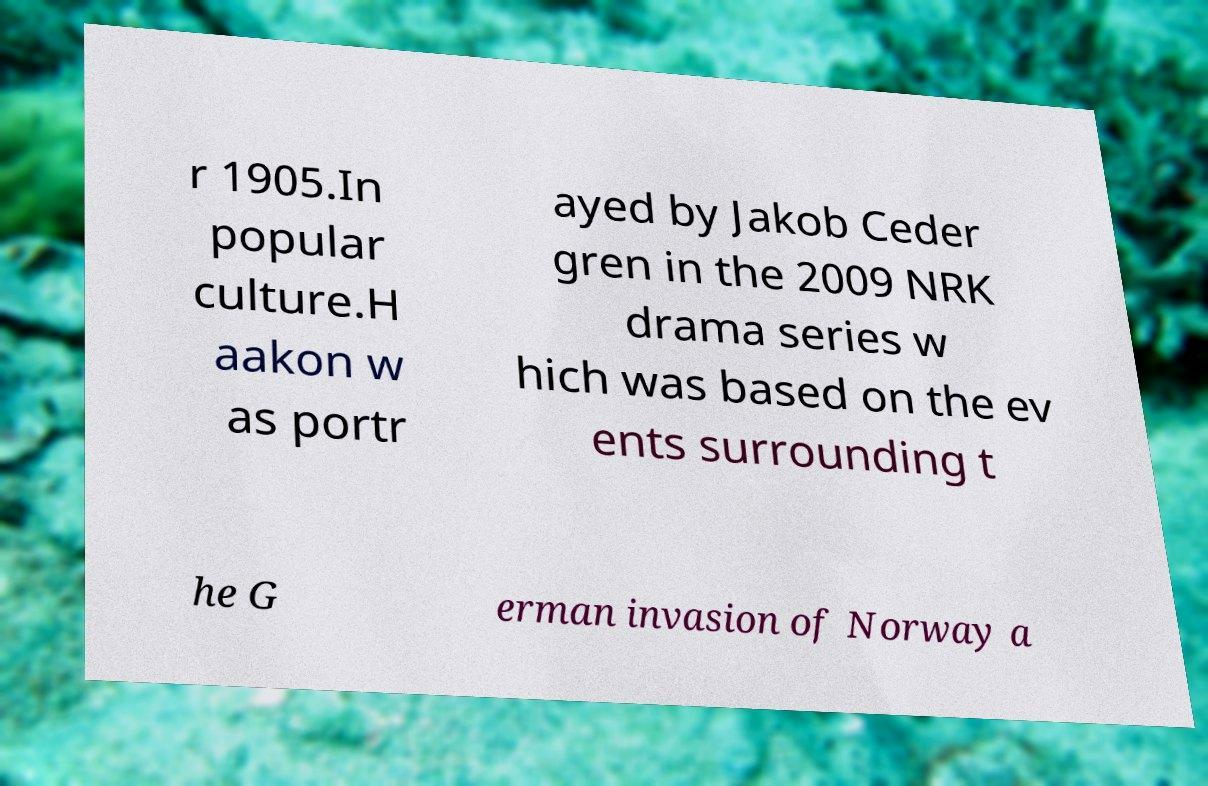Could you extract and type out the text from this image? r 1905.In popular culture.H aakon w as portr ayed by Jakob Ceder gren in the 2009 NRK drama series w hich was based on the ev ents surrounding t he G erman invasion of Norway a 